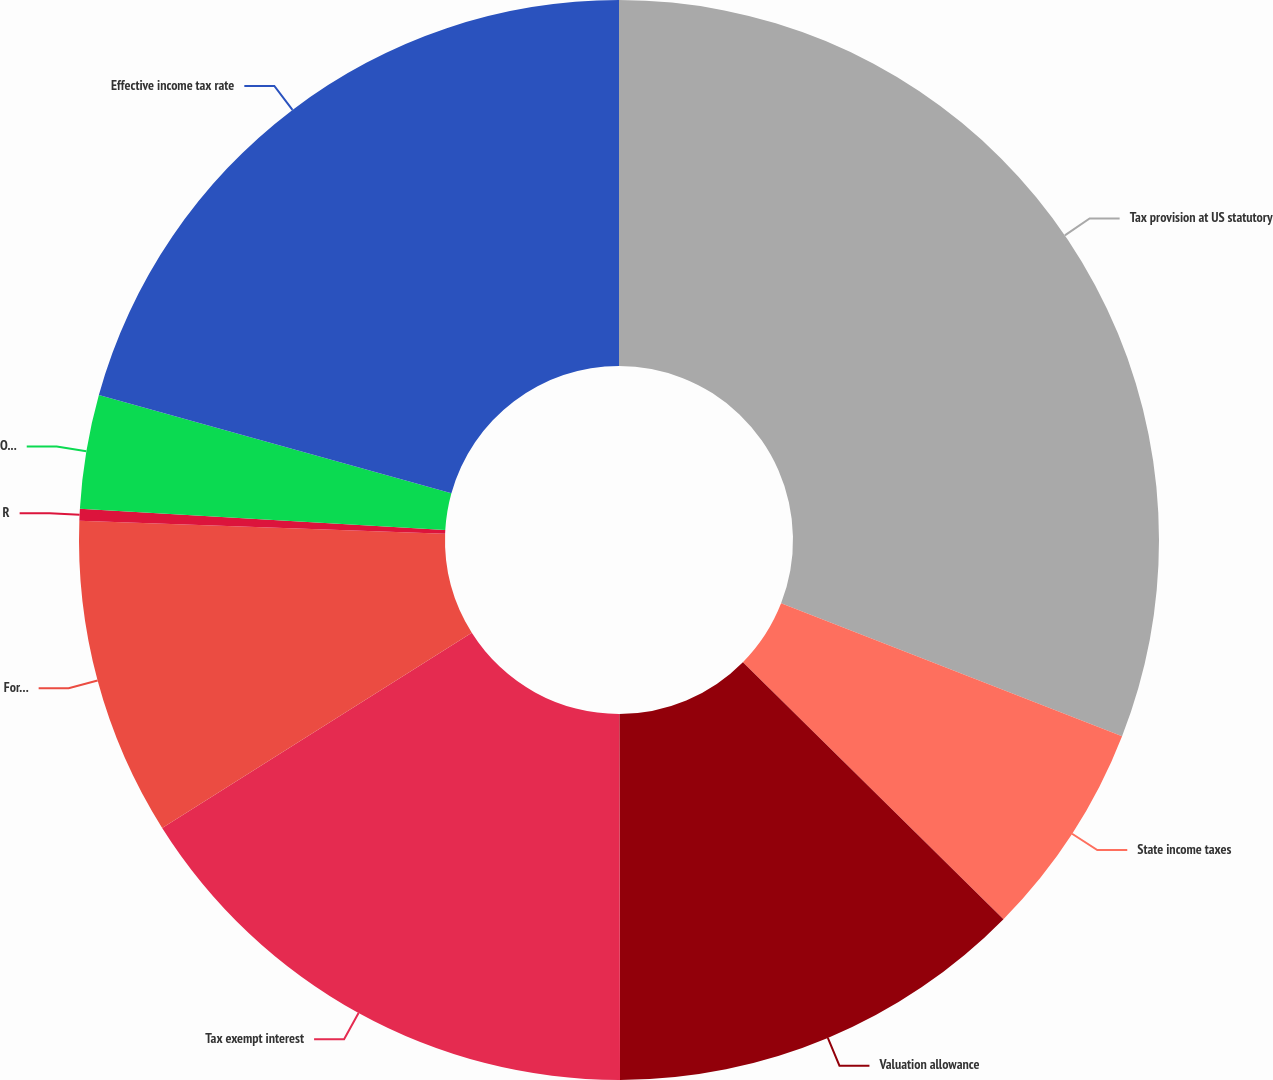<chart> <loc_0><loc_0><loc_500><loc_500><pie_chart><fcel>Tax provision at US statutory<fcel>State income taxes<fcel>Valuation allowance<fcel>Tax exempt interest<fcel>Foreign tax rate differential<fcel>Repatriation of foreign<fcel>Other - net<fcel>Effective income tax rate<nl><fcel>30.92%<fcel>6.47%<fcel>12.58%<fcel>16.08%<fcel>9.52%<fcel>0.35%<fcel>3.41%<fcel>20.67%<nl></chart> 